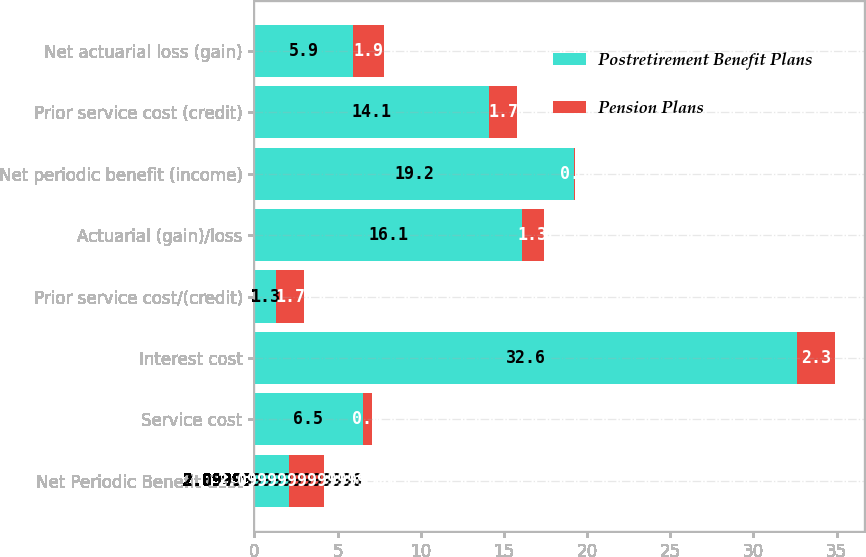Convert chart. <chart><loc_0><loc_0><loc_500><loc_500><stacked_bar_chart><ecel><fcel>Net Periodic Benefit Cost<fcel>Service cost<fcel>Interest cost<fcel>Prior service cost/(credit)<fcel>Actuarial (gain)/loss<fcel>Net periodic benefit (income)<fcel>Prior service cost (credit)<fcel>Net actuarial loss (gain)<nl><fcel>Postretirement Benefit Plans<fcel>2.1<fcel>6.5<fcel>32.6<fcel>1.3<fcel>16.1<fcel>19.2<fcel>14.1<fcel>5.9<nl><fcel>Pension Plans<fcel>2.1<fcel>0.6<fcel>2.3<fcel>1.7<fcel>1.3<fcel>0.1<fcel>1.7<fcel>1.9<nl></chart> 